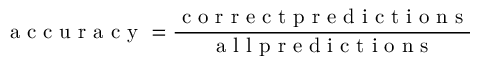<formula> <loc_0><loc_0><loc_500><loc_500>a c c u r a c y = \frac { c o r r e c t p r e d i c t i o n s } { a l l p r e d i c t i o n s }</formula> 